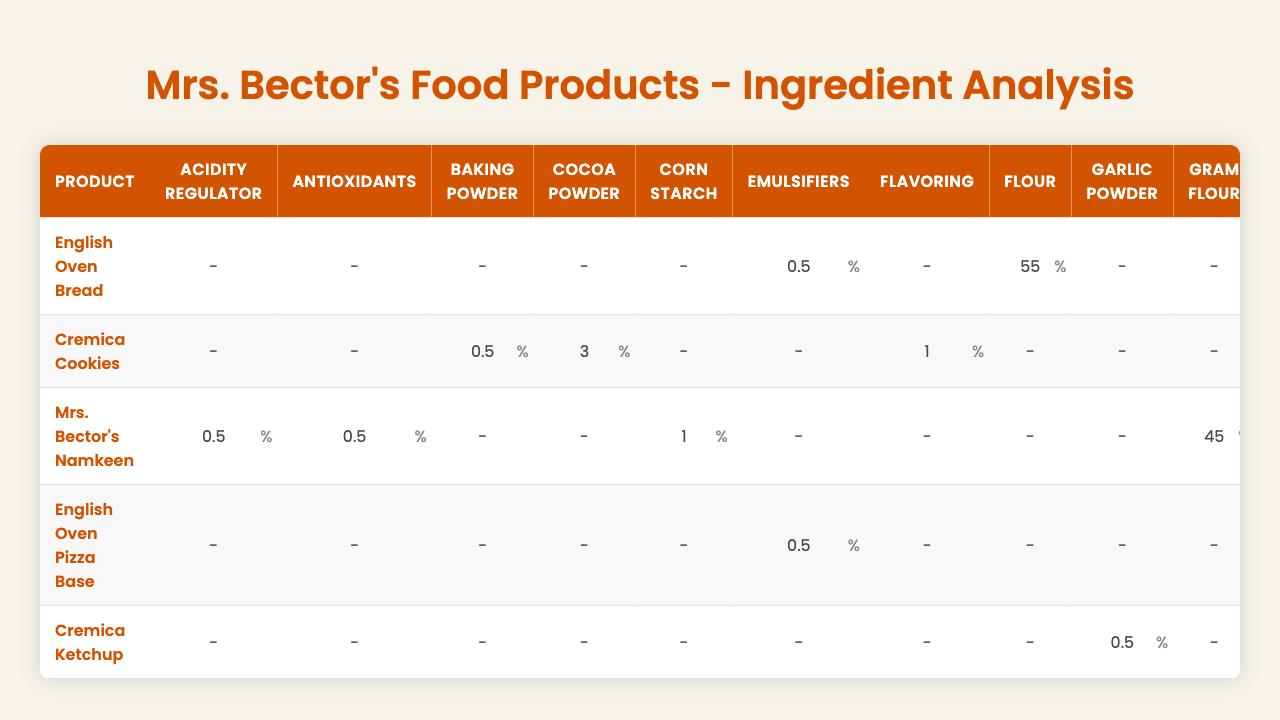What is the main ingredient in the English Oven Bread? The table shows that the main ingredient in the English Oven Bread is flour, which makes up 55% of the composition.
Answer: Flour Which product contains the highest percentage of sugar? By comparing the sugar percentages in the table, Cremica Cookies contains 25%, which is higher than the other products listed.
Answer: Cremica Cookies Is there any product that contains preservatives? Yes, multiple products include preservatives according to the table. Notably, English Oven Bread, Cremica Cookies, English Oven Pizza Base, Cremica Ketchup, and Mrs. Bector's Namkeen all have preservative content listed.
Answer: Yes What is the total percentage of vegetable oil in Mrs. Bector's Namkeen and Cremica Cookies? The vegetable oil in Mrs. Bector's Namkeen is 30%, and in Cremica Cookies, it is 20%. Adding them gives 30 + 20 = 50%.
Answer: 50% Which product has the lowest salt content? Evaluating the salt percentages, Cremica Cookies has the lowest salt at 0.5%, compared to others like English Oven Pizza Base and Mrs. Bector's Namkeen, which have higher amounts.
Answer: Cremica Cookies Calculate the average flour percentage across all products listed. Collecting the flour percentages: English Oven Bread (55), English Oven Pizza Base (60), Cremica Cookies (40) has 'wheat flour' instead, and Mrs. Bector's Namkeen has 'gram flour' (45). Totaling these gives 200. Divided by 4 products with flour = 200 / 4 = 50%.
Answer: 50% Does the English Oven Pizza Base contain any vitamins? The table indicates that the English Oven Pizza Base does not list vitamins as part of its ingredient composition.
Answer: No Which product contains the highest amount of cocoa powder? The only product that contains cocoa powder is Cremica Cookies, which has 3%. Thus, it is the highest in comparison to other products as none have cocoa powder listed.
Answer: Cremica Cookies If we sum all the ingredients of English Oven Bread, what is the total percentage? The total for English Oven Bread is calculated as follows: 55 (flour) + 35 (water) + 2 (yeast) + 1 (salt) + 3 (sugar) + 2 (vegetable oil) + 0.5 (preservatives) + 0.5 (emulsifiers) + 1 (vitamins) = 100%.
Answer: 100% Which product has the second-highest vegetable oil content after Mrs. Bector's Namkeen? In the table, Mrs. Bector's Namkeen has 30% vegetable oil, the next product with the highest content is Cremica Cookies at 20%. Therefore, Cremica Cookies ranks second after Mrs. Bector's Namkeen.
Answer: Cremica Cookies What is the total sugar content in the English Oven Bread and English Oven Pizza Base? For the English Oven Bread, sugar is at 3%, and in the English Oven Pizza Base, it is 2%. Adding these gives 3 + 2 = 5%.
Answer: 5% 